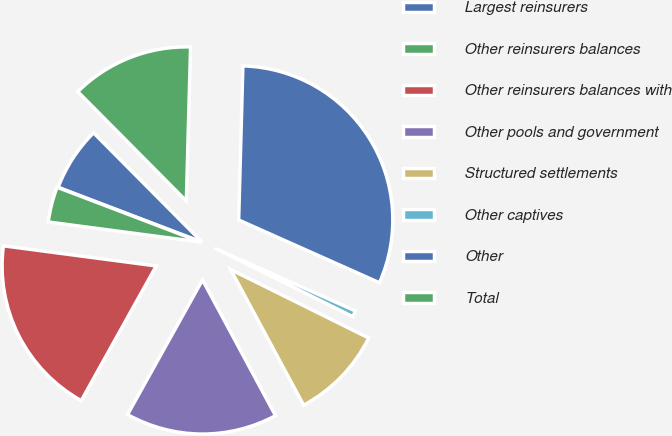<chart> <loc_0><loc_0><loc_500><loc_500><pie_chart><fcel>Largest reinsurers<fcel>Other reinsurers balances<fcel>Other reinsurers balances with<fcel>Other pools and government<fcel>Structured settlements<fcel>Other captives<fcel>Other<fcel>Total<nl><fcel>6.76%<fcel>3.71%<fcel>19.0%<fcel>15.94%<fcel>9.82%<fcel>0.65%<fcel>31.24%<fcel>12.88%<nl></chart> 